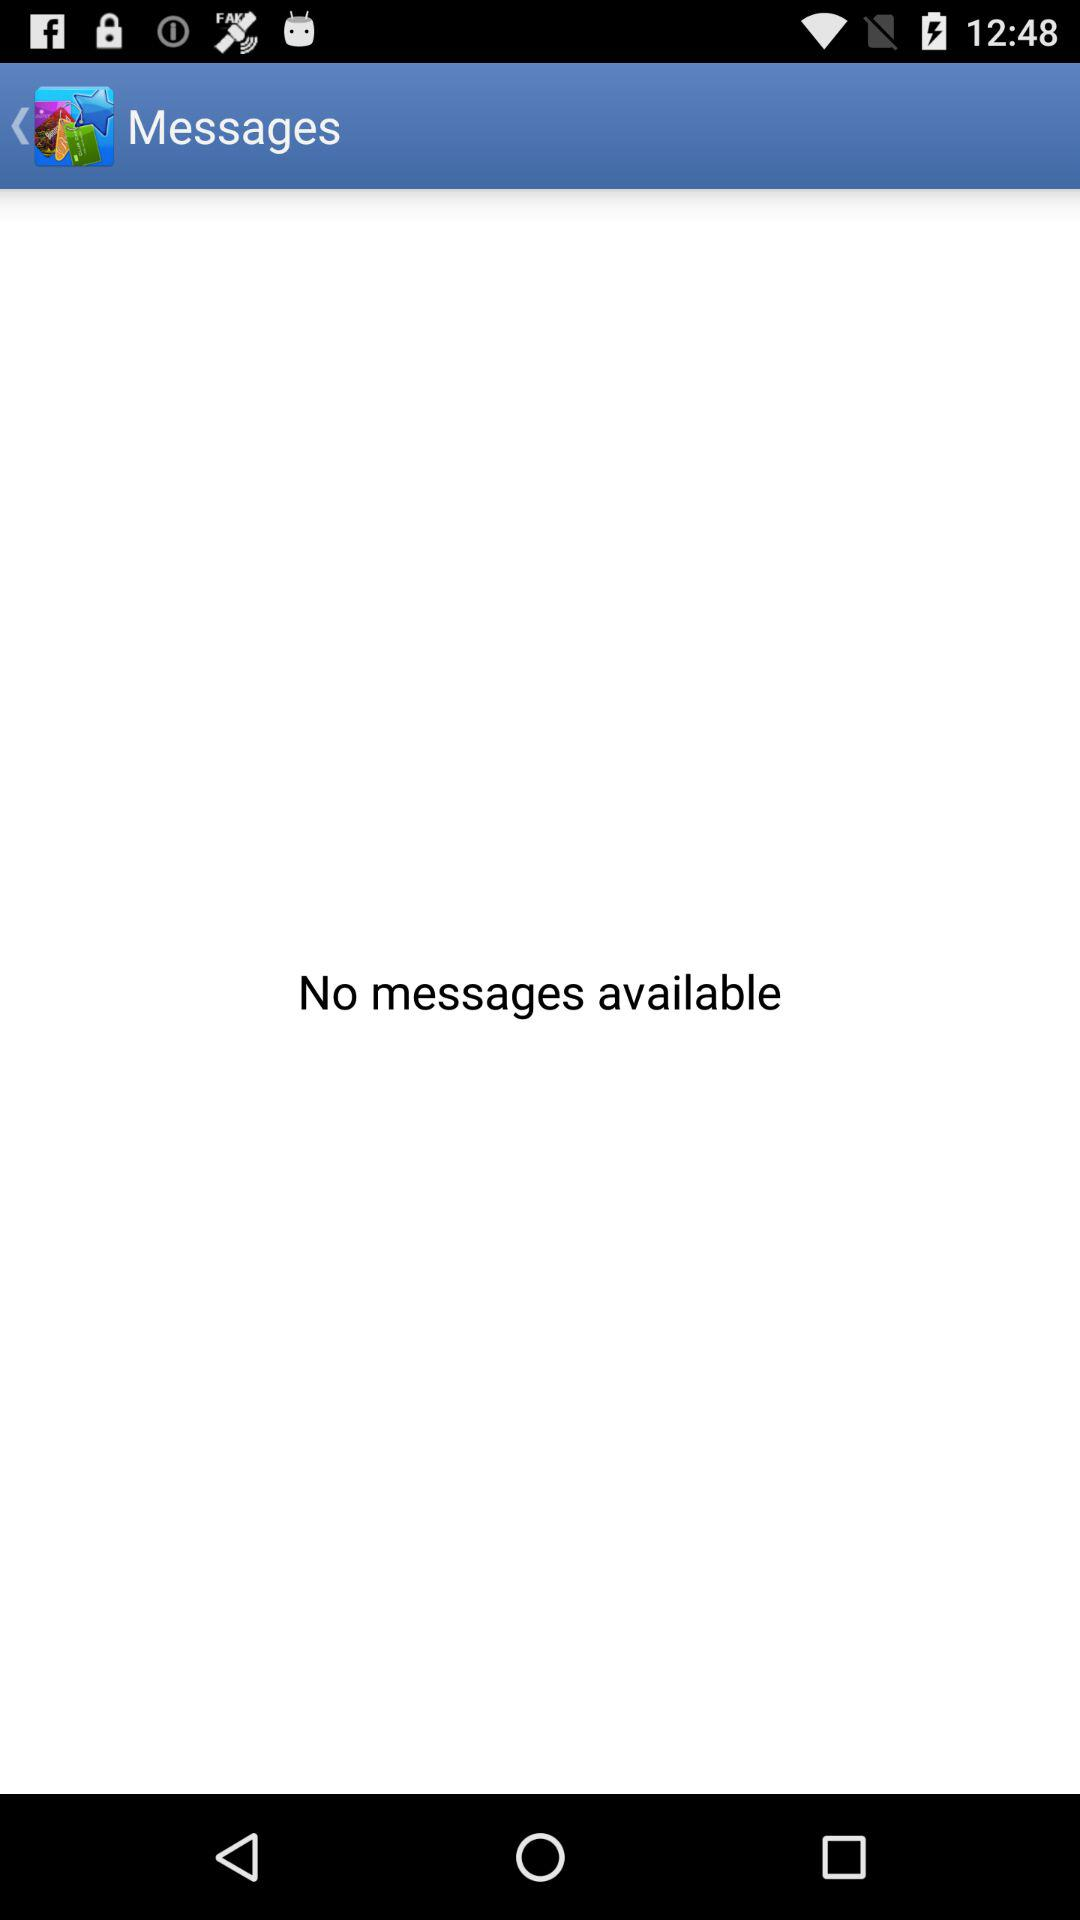How many messages are there?
Answer the question using a single word or phrase. 0 